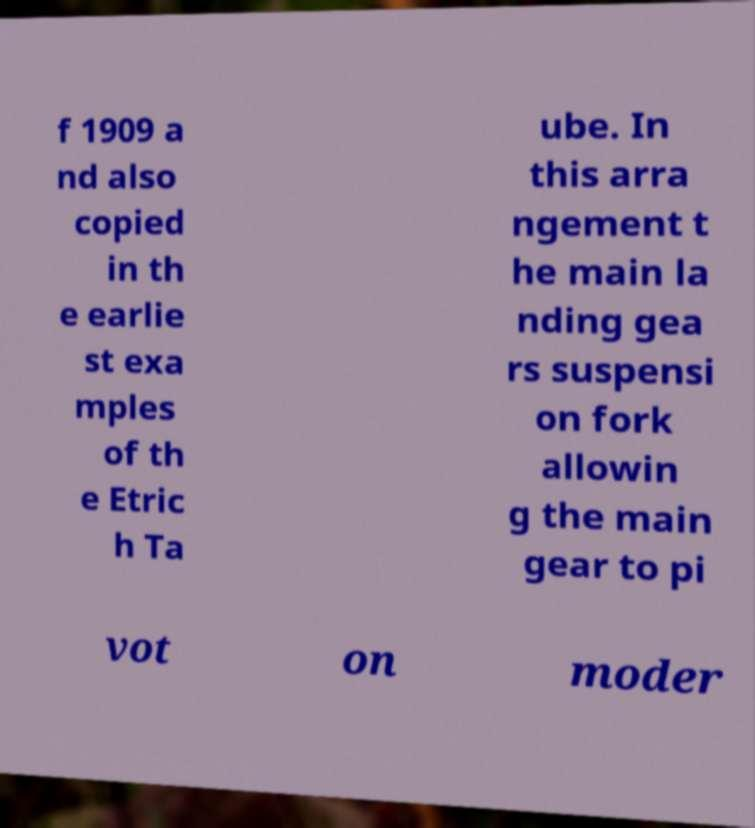Can you read and provide the text displayed in the image?This photo seems to have some interesting text. Can you extract and type it out for me? f 1909 a nd also copied in th e earlie st exa mples of th e Etric h Ta ube. In this arra ngement t he main la nding gea rs suspensi on fork allowin g the main gear to pi vot on moder 